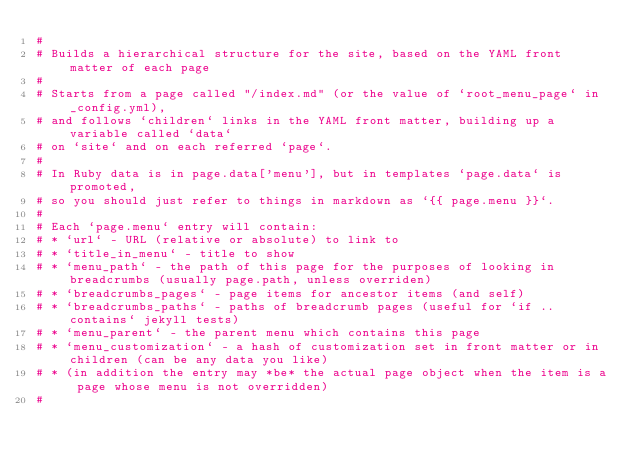Convert code to text. <code><loc_0><loc_0><loc_500><loc_500><_Ruby_>#
# Builds a hierarchical structure for the site, based on the YAML front matter of each page
#
# Starts from a page called "/index.md" (or the value of `root_menu_page` in _config.yml),
# and follows `children` links in the YAML front matter, building up a variable called `data`
# on `site` and on each referred `page`.
#
# In Ruby data is in page.data['menu'], but in templates `page.data` is promoted,
# so you should just refer to things in markdown as `{{ page.menu }}`.
#
# Each `page.menu` entry will contain:
# * `url` - URL (relative or absolute) to link to
# * `title_in_menu` - title to show
# * `menu_path` - the path of this page for the purposes of looking in breadcrumbs (usually page.path, unless overriden)
# * `breadcrumbs_pages` - page items for ancestor items (and self)
# * `breadcrumbs_paths` - paths of breadcrumb pages (useful for `if .. contains` jekyll tests)
# * `menu_parent` - the parent menu which contains this page
# * `menu_customization` - a hash of customization set in front matter or in children (can be any data you like)
# * (in addition the entry may *be* the actual page object when the item is a page whose menu is not overridden)
#</code> 